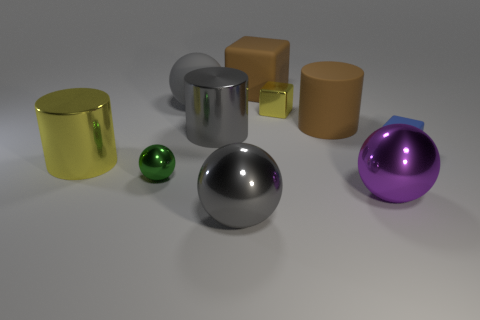Subtract all blue cubes. How many cubes are left? 2 Subtract all cyan cubes. How many gray spheres are left? 2 Subtract 2 balls. How many balls are left? 2 Subtract all brown cylinders. How many cylinders are left? 2 Subtract all blocks. How many objects are left? 7 Subtract all red cubes. Subtract all red spheres. How many cubes are left? 3 Subtract all large red matte balls. Subtract all brown things. How many objects are left? 8 Add 1 small blue blocks. How many small blue blocks are left? 2 Add 7 yellow cylinders. How many yellow cylinders exist? 8 Subtract 0 red balls. How many objects are left? 10 